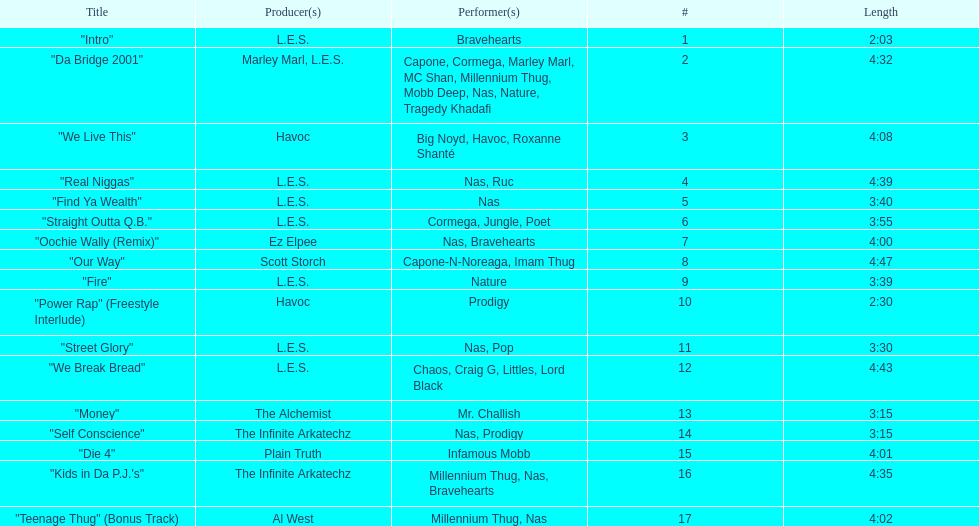After street glory, what song is listed? "We Break Bread". Parse the full table. {'header': ['Title', 'Producer(s)', 'Performer(s)', '#', 'Length'], 'rows': [['"Intro"', 'L.E.S.', 'Bravehearts', '1', '2:03'], ['"Da Bridge 2001"', 'Marley Marl, L.E.S.', 'Capone, Cormega, Marley Marl, MC Shan, Millennium Thug, Mobb Deep, Nas, Nature, Tragedy Khadafi', '2', '4:32'], ['"We Live This"', 'Havoc', 'Big Noyd, Havoc, Roxanne Shanté', '3', '4:08'], ['"Real Niggas"', 'L.E.S.', 'Nas, Ruc', '4', '4:39'], ['"Find Ya Wealth"', 'L.E.S.', 'Nas', '5', '3:40'], ['"Straight Outta Q.B."', 'L.E.S.', 'Cormega, Jungle, Poet', '6', '3:55'], ['"Oochie Wally (Remix)"', 'Ez Elpee', 'Nas, Bravehearts', '7', '4:00'], ['"Our Way"', 'Scott Storch', 'Capone-N-Noreaga, Imam Thug', '8', '4:47'], ['"Fire"', 'L.E.S.', 'Nature', '9', '3:39'], ['"Power Rap" (Freestyle Interlude)', 'Havoc', 'Prodigy', '10', '2:30'], ['"Street Glory"', 'L.E.S.', 'Nas, Pop', '11', '3:30'], ['"We Break Bread"', 'L.E.S.', 'Chaos, Craig G, Littles, Lord Black', '12', '4:43'], ['"Money"', 'The Alchemist', 'Mr. Challish', '13', '3:15'], ['"Self Conscience"', 'The Infinite Arkatechz', 'Nas, Prodigy', '14', '3:15'], ['"Die 4"', 'Plain Truth', 'Infamous Mobb', '15', '4:01'], ['"Kids in Da P.J.\'s"', 'The Infinite Arkatechz', 'Millennium Thug, Nas, Bravehearts', '16', '4:35'], ['"Teenage Thug" (Bonus Track)', 'Al West', 'Millennium Thug, Nas', '17', '4:02']]} 